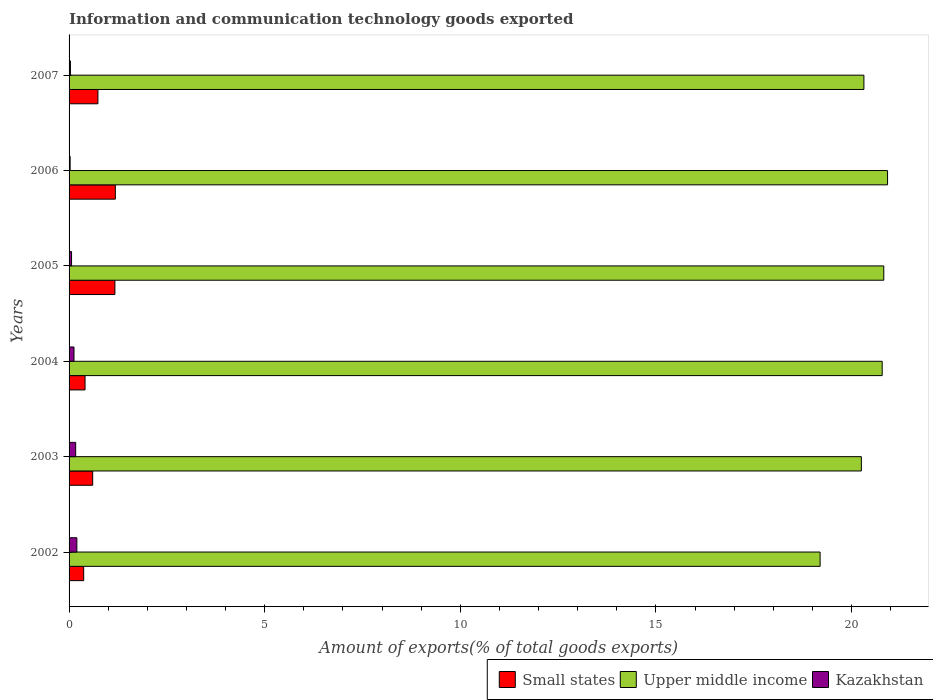How many different coloured bars are there?
Your response must be concise. 3. Are the number of bars per tick equal to the number of legend labels?
Make the answer very short. Yes. Are the number of bars on each tick of the Y-axis equal?
Keep it short and to the point. Yes. How many bars are there on the 1st tick from the top?
Give a very brief answer. 3. How many bars are there on the 6th tick from the bottom?
Offer a very short reply. 3. In how many cases, is the number of bars for a given year not equal to the number of legend labels?
Provide a succinct answer. 0. What is the amount of goods exported in Upper middle income in 2003?
Provide a succinct answer. 20.25. Across all years, what is the maximum amount of goods exported in Small states?
Keep it short and to the point. 1.18. Across all years, what is the minimum amount of goods exported in Small states?
Provide a short and direct response. 0.37. In which year was the amount of goods exported in Upper middle income maximum?
Give a very brief answer. 2006. What is the total amount of goods exported in Upper middle income in the graph?
Your answer should be very brief. 122.3. What is the difference between the amount of goods exported in Kazakhstan in 2002 and that in 2005?
Provide a short and direct response. 0.14. What is the difference between the amount of goods exported in Kazakhstan in 2004 and the amount of goods exported in Small states in 2005?
Your response must be concise. -1.05. What is the average amount of goods exported in Kazakhstan per year?
Your response must be concise. 0.1. In the year 2006, what is the difference between the amount of goods exported in Kazakhstan and amount of goods exported in Small states?
Your response must be concise. -1.16. In how many years, is the amount of goods exported in Small states greater than 6 %?
Make the answer very short. 0. What is the ratio of the amount of goods exported in Kazakhstan in 2004 to that in 2005?
Ensure brevity in your answer.  1.99. Is the difference between the amount of goods exported in Kazakhstan in 2003 and 2007 greater than the difference between the amount of goods exported in Small states in 2003 and 2007?
Ensure brevity in your answer.  Yes. What is the difference between the highest and the second highest amount of goods exported in Kazakhstan?
Your response must be concise. 0.03. What is the difference between the highest and the lowest amount of goods exported in Small states?
Provide a short and direct response. 0.81. In how many years, is the amount of goods exported in Upper middle income greater than the average amount of goods exported in Upper middle income taken over all years?
Your answer should be compact. 3. Is the sum of the amount of goods exported in Upper middle income in 2002 and 2004 greater than the maximum amount of goods exported in Small states across all years?
Offer a very short reply. Yes. What does the 2nd bar from the top in 2006 represents?
Ensure brevity in your answer.  Upper middle income. What does the 3rd bar from the bottom in 2005 represents?
Offer a very short reply. Kazakhstan. Are all the bars in the graph horizontal?
Your response must be concise. Yes. How many years are there in the graph?
Provide a succinct answer. 6. Does the graph contain any zero values?
Keep it short and to the point. No. Where does the legend appear in the graph?
Give a very brief answer. Bottom right. How many legend labels are there?
Your answer should be compact. 3. What is the title of the graph?
Your answer should be very brief. Information and communication technology goods exported. Does "Aruba" appear as one of the legend labels in the graph?
Your response must be concise. No. What is the label or title of the X-axis?
Offer a terse response. Amount of exports(% of total goods exports). What is the Amount of exports(% of total goods exports) of Small states in 2002?
Your answer should be compact. 0.37. What is the Amount of exports(% of total goods exports) of Upper middle income in 2002?
Make the answer very short. 19.2. What is the Amount of exports(% of total goods exports) of Kazakhstan in 2002?
Your answer should be very brief. 0.2. What is the Amount of exports(% of total goods exports) of Small states in 2003?
Provide a succinct answer. 0.6. What is the Amount of exports(% of total goods exports) of Upper middle income in 2003?
Your response must be concise. 20.25. What is the Amount of exports(% of total goods exports) of Kazakhstan in 2003?
Give a very brief answer. 0.17. What is the Amount of exports(% of total goods exports) in Small states in 2004?
Ensure brevity in your answer.  0.41. What is the Amount of exports(% of total goods exports) of Upper middle income in 2004?
Provide a succinct answer. 20.78. What is the Amount of exports(% of total goods exports) of Kazakhstan in 2004?
Your response must be concise. 0.13. What is the Amount of exports(% of total goods exports) in Small states in 2005?
Keep it short and to the point. 1.17. What is the Amount of exports(% of total goods exports) in Upper middle income in 2005?
Keep it short and to the point. 20.83. What is the Amount of exports(% of total goods exports) of Kazakhstan in 2005?
Keep it short and to the point. 0.06. What is the Amount of exports(% of total goods exports) in Small states in 2006?
Your response must be concise. 1.18. What is the Amount of exports(% of total goods exports) in Upper middle income in 2006?
Provide a short and direct response. 20.92. What is the Amount of exports(% of total goods exports) of Kazakhstan in 2006?
Provide a succinct answer. 0.03. What is the Amount of exports(% of total goods exports) in Small states in 2007?
Your answer should be compact. 0.74. What is the Amount of exports(% of total goods exports) in Upper middle income in 2007?
Ensure brevity in your answer.  20.32. What is the Amount of exports(% of total goods exports) of Kazakhstan in 2007?
Your answer should be very brief. 0.03. Across all years, what is the maximum Amount of exports(% of total goods exports) of Small states?
Keep it short and to the point. 1.18. Across all years, what is the maximum Amount of exports(% of total goods exports) in Upper middle income?
Your answer should be compact. 20.92. Across all years, what is the maximum Amount of exports(% of total goods exports) in Kazakhstan?
Your answer should be very brief. 0.2. Across all years, what is the minimum Amount of exports(% of total goods exports) in Small states?
Give a very brief answer. 0.37. Across all years, what is the minimum Amount of exports(% of total goods exports) in Upper middle income?
Make the answer very short. 19.2. Across all years, what is the minimum Amount of exports(% of total goods exports) in Kazakhstan?
Your response must be concise. 0.03. What is the total Amount of exports(% of total goods exports) of Small states in the graph?
Give a very brief answer. 4.48. What is the total Amount of exports(% of total goods exports) of Upper middle income in the graph?
Keep it short and to the point. 122.3. What is the total Amount of exports(% of total goods exports) in Kazakhstan in the graph?
Provide a short and direct response. 0.62. What is the difference between the Amount of exports(% of total goods exports) of Small states in 2002 and that in 2003?
Provide a short and direct response. -0.23. What is the difference between the Amount of exports(% of total goods exports) of Upper middle income in 2002 and that in 2003?
Your answer should be very brief. -1.05. What is the difference between the Amount of exports(% of total goods exports) of Kazakhstan in 2002 and that in 2003?
Offer a very short reply. 0.03. What is the difference between the Amount of exports(% of total goods exports) of Small states in 2002 and that in 2004?
Give a very brief answer. -0.03. What is the difference between the Amount of exports(% of total goods exports) of Upper middle income in 2002 and that in 2004?
Offer a terse response. -1.59. What is the difference between the Amount of exports(% of total goods exports) in Kazakhstan in 2002 and that in 2004?
Make the answer very short. 0.07. What is the difference between the Amount of exports(% of total goods exports) in Small states in 2002 and that in 2005?
Your answer should be very brief. -0.8. What is the difference between the Amount of exports(% of total goods exports) in Upper middle income in 2002 and that in 2005?
Give a very brief answer. -1.63. What is the difference between the Amount of exports(% of total goods exports) in Kazakhstan in 2002 and that in 2005?
Make the answer very short. 0.14. What is the difference between the Amount of exports(% of total goods exports) in Small states in 2002 and that in 2006?
Give a very brief answer. -0.81. What is the difference between the Amount of exports(% of total goods exports) in Upper middle income in 2002 and that in 2006?
Provide a short and direct response. -1.72. What is the difference between the Amount of exports(% of total goods exports) in Kazakhstan in 2002 and that in 2006?
Keep it short and to the point. 0.17. What is the difference between the Amount of exports(% of total goods exports) in Small states in 2002 and that in 2007?
Provide a succinct answer. -0.36. What is the difference between the Amount of exports(% of total goods exports) of Upper middle income in 2002 and that in 2007?
Offer a terse response. -1.12. What is the difference between the Amount of exports(% of total goods exports) in Kazakhstan in 2002 and that in 2007?
Your answer should be compact. 0.16. What is the difference between the Amount of exports(% of total goods exports) in Small states in 2003 and that in 2004?
Keep it short and to the point. 0.2. What is the difference between the Amount of exports(% of total goods exports) in Upper middle income in 2003 and that in 2004?
Make the answer very short. -0.53. What is the difference between the Amount of exports(% of total goods exports) in Kazakhstan in 2003 and that in 2004?
Give a very brief answer. 0.04. What is the difference between the Amount of exports(% of total goods exports) of Small states in 2003 and that in 2005?
Your answer should be compact. -0.57. What is the difference between the Amount of exports(% of total goods exports) in Upper middle income in 2003 and that in 2005?
Keep it short and to the point. -0.57. What is the difference between the Amount of exports(% of total goods exports) of Kazakhstan in 2003 and that in 2005?
Provide a short and direct response. 0.11. What is the difference between the Amount of exports(% of total goods exports) in Small states in 2003 and that in 2006?
Give a very brief answer. -0.58. What is the difference between the Amount of exports(% of total goods exports) of Upper middle income in 2003 and that in 2006?
Make the answer very short. -0.67. What is the difference between the Amount of exports(% of total goods exports) of Kazakhstan in 2003 and that in 2006?
Your answer should be compact. 0.14. What is the difference between the Amount of exports(% of total goods exports) of Small states in 2003 and that in 2007?
Make the answer very short. -0.13. What is the difference between the Amount of exports(% of total goods exports) of Upper middle income in 2003 and that in 2007?
Your answer should be compact. -0.06. What is the difference between the Amount of exports(% of total goods exports) of Kazakhstan in 2003 and that in 2007?
Ensure brevity in your answer.  0.13. What is the difference between the Amount of exports(% of total goods exports) in Small states in 2004 and that in 2005?
Your response must be concise. -0.76. What is the difference between the Amount of exports(% of total goods exports) of Upper middle income in 2004 and that in 2005?
Offer a very short reply. -0.04. What is the difference between the Amount of exports(% of total goods exports) of Kazakhstan in 2004 and that in 2005?
Provide a short and direct response. 0.06. What is the difference between the Amount of exports(% of total goods exports) of Small states in 2004 and that in 2006?
Your answer should be compact. -0.77. What is the difference between the Amount of exports(% of total goods exports) of Upper middle income in 2004 and that in 2006?
Offer a terse response. -0.14. What is the difference between the Amount of exports(% of total goods exports) of Kazakhstan in 2004 and that in 2006?
Ensure brevity in your answer.  0.1. What is the difference between the Amount of exports(% of total goods exports) in Small states in 2004 and that in 2007?
Your answer should be very brief. -0.33. What is the difference between the Amount of exports(% of total goods exports) of Upper middle income in 2004 and that in 2007?
Make the answer very short. 0.47. What is the difference between the Amount of exports(% of total goods exports) of Kazakhstan in 2004 and that in 2007?
Keep it short and to the point. 0.09. What is the difference between the Amount of exports(% of total goods exports) of Small states in 2005 and that in 2006?
Offer a terse response. -0.01. What is the difference between the Amount of exports(% of total goods exports) in Upper middle income in 2005 and that in 2006?
Provide a succinct answer. -0.1. What is the difference between the Amount of exports(% of total goods exports) in Kazakhstan in 2005 and that in 2006?
Make the answer very short. 0.04. What is the difference between the Amount of exports(% of total goods exports) in Small states in 2005 and that in 2007?
Give a very brief answer. 0.43. What is the difference between the Amount of exports(% of total goods exports) in Upper middle income in 2005 and that in 2007?
Your answer should be compact. 0.51. What is the difference between the Amount of exports(% of total goods exports) of Kazakhstan in 2005 and that in 2007?
Keep it short and to the point. 0.03. What is the difference between the Amount of exports(% of total goods exports) of Small states in 2006 and that in 2007?
Ensure brevity in your answer.  0.45. What is the difference between the Amount of exports(% of total goods exports) in Upper middle income in 2006 and that in 2007?
Your answer should be compact. 0.6. What is the difference between the Amount of exports(% of total goods exports) in Kazakhstan in 2006 and that in 2007?
Provide a short and direct response. -0.01. What is the difference between the Amount of exports(% of total goods exports) of Small states in 2002 and the Amount of exports(% of total goods exports) of Upper middle income in 2003?
Offer a very short reply. -19.88. What is the difference between the Amount of exports(% of total goods exports) of Small states in 2002 and the Amount of exports(% of total goods exports) of Kazakhstan in 2003?
Offer a terse response. 0.2. What is the difference between the Amount of exports(% of total goods exports) in Upper middle income in 2002 and the Amount of exports(% of total goods exports) in Kazakhstan in 2003?
Your answer should be very brief. 19.03. What is the difference between the Amount of exports(% of total goods exports) in Small states in 2002 and the Amount of exports(% of total goods exports) in Upper middle income in 2004?
Give a very brief answer. -20.41. What is the difference between the Amount of exports(% of total goods exports) of Small states in 2002 and the Amount of exports(% of total goods exports) of Kazakhstan in 2004?
Provide a succinct answer. 0.25. What is the difference between the Amount of exports(% of total goods exports) of Upper middle income in 2002 and the Amount of exports(% of total goods exports) of Kazakhstan in 2004?
Your response must be concise. 19.07. What is the difference between the Amount of exports(% of total goods exports) of Small states in 2002 and the Amount of exports(% of total goods exports) of Upper middle income in 2005?
Provide a short and direct response. -20.45. What is the difference between the Amount of exports(% of total goods exports) in Small states in 2002 and the Amount of exports(% of total goods exports) in Kazakhstan in 2005?
Keep it short and to the point. 0.31. What is the difference between the Amount of exports(% of total goods exports) of Upper middle income in 2002 and the Amount of exports(% of total goods exports) of Kazakhstan in 2005?
Your answer should be very brief. 19.13. What is the difference between the Amount of exports(% of total goods exports) of Small states in 2002 and the Amount of exports(% of total goods exports) of Upper middle income in 2006?
Your answer should be very brief. -20.55. What is the difference between the Amount of exports(% of total goods exports) of Small states in 2002 and the Amount of exports(% of total goods exports) of Kazakhstan in 2006?
Keep it short and to the point. 0.35. What is the difference between the Amount of exports(% of total goods exports) of Upper middle income in 2002 and the Amount of exports(% of total goods exports) of Kazakhstan in 2006?
Offer a very short reply. 19.17. What is the difference between the Amount of exports(% of total goods exports) in Small states in 2002 and the Amount of exports(% of total goods exports) in Upper middle income in 2007?
Your answer should be very brief. -19.94. What is the difference between the Amount of exports(% of total goods exports) of Small states in 2002 and the Amount of exports(% of total goods exports) of Kazakhstan in 2007?
Offer a very short reply. 0.34. What is the difference between the Amount of exports(% of total goods exports) in Upper middle income in 2002 and the Amount of exports(% of total goods exports) in Kazakhstan in 2007?
Ensure brevity in your answer.  19.16. What is the difference between the Amount of exports(% of total goods exports) in Small states in 2003 and the Amount of exports(% of total goods exports) in Upper middle income in 2004?
Your response must be concise. -20.18. What is the difference between the Amount of exports(% of total goods exports) in Small states in 2003 and the Amount of exports(% of total goods exports) in Kazakhstan in 2004?
Provide a succinct answer. 0.48. What is the difference between the Amount of exports(% of total goods exports) of Upper middle income in 2003 and the Amount of exports(% of total goods exports) of Kazakhstan in 2004?
Keep it short and to the point. 20.13. What is the difference between the Amount of exports(% of total goods exports) in Small states in 2003 and the Amount of exports(% of total goods exports) in Upper middle income in 2005?
Provide a short and direct response. -20.22. What is the difference between the Amount of exports(% of total goods exports) of Small states in 2003 and the Amount of exports(% of total goods exports) of Kazakhstan in 2005?
Keep it short and to the point. 0.54. What is the difference between the Amount of exports(% of total goods exports) in Upper middle income in 2003 and the Amount of exports(% of total goods exports) in Kazakhstan in 2005?
Offer a terse response. 20.19. What is the difference between the Amount of exports(% of total goods exports) of Small states in 2003 and the Amount of exports(% of total goods exports) of Upper middle income in 2006?
Make the answer very short. -20.32. What is the difference between the Amount of exports(% of total goods exports) of Small states in 2003 and the Amount of exports(% of total goods exports) of Kazakhstan in 2006?
Your response must be concise. 0.58. What is the difference between the Amount of exports(% of total goods exports) in Upper middle income in 2003 and the Amount of exports(% of total goods exports) in Kazakhstan in 2006?
Provide a short and direct response. 20.22. What is the difference between the Amount of exports(% of total goods exports) in Small states in 2003 and the Amount of exports(% of total goods exports) in Upper middle income in 2007?
Your answer should be very brief. -19.71. What is the difference between the Amount of exports(% of total goods exports) of Small states in 2003 and the Amount of exports(% of total goods exports) of Kazakhstan in 2007?
Give a very brief answer. 0.57. What is the difference between the Amount of exports(% of total goods exports) in Upper middle income in 2003 and the Amount of exports(% of total goods exports) in Kazakhstan in 2007?
Give a very brief answer. 20.22. What is the difference between the Amount of exports(% of total goods exports) in Small states in 2004 and the Amount of exports(% of total goods exports) in Upper middle income in 2005?
Give a very brief answer. -20.42. What is the difference between the Amount of exports(% of total goods exports) of Small states in 2004 and the Amount of exports(% of total goods exports) of Kazakhstan in 2005?
Your response must be concise. 0.35. What is the difference between the Amount of exports(% of total goods exports) of Upper middle income in 2004 and the Amount of exports(% of total goods exports) of Kazakhstan in 2005?
Offer a terse response. 20.72. What is the difference between the Amount of exports(% of total goods exports) in Small states in 2004 and the Amount of exports(% of total goods exports) in Upper middle income in 2006?
Your response must be concise. -20.51. What is the difference between the Amount of exports(% of total goods exports) in Small states in 2004 and the Amount of exports(% of total goods exports) in Kazakhstan in 2006?
Ensure brevity in your answer.  0.38. What is the difference between the Amount of exports(% of total goods exports) of Upper middle income in 2004 and the Amount of exports(% of total goods exports) of Kazakhstan in 2006?
Your response must be concise. 20.76. What is the difference between the Amount of exports(% of total goods exports) of Small states in 2004 and the Amount of exports(% of total goods exports) of Upper middle income in 2007?
Make the answer very short. -19.91. What is the difference between the Amount of exports(% of total goods exports) in Small states in 2004 and the Amount of exports(% of total goods exports) in Kazakhstan in 2007?
Provide a short and direct response. 0.37. What is the difference between the Amount of exports(% of total goods exports) of Upper middle income in 2004 and the Amount of exports(% of total goods exports) of Kazakhstan in 2007?
Keep it short and to the point. 20.75. What is the difference between the Amount of exports(% of total goods exports) in Small states in 2005 and the Amount of exports(% of total goods exports) in Upper middle income in 2006?
Keep it short and to the point. -19.75. What is the difference between the Amount of exports(% of total goods exports) of Small states in 2005 and the Amount of exports(% of total goods exports) of Kazakhstan in 2006?
Provide a succinct answer. 1.14. What is the difference between the Amount of exports(% of total goods exports) of Upper middle income in 2005 and the Amount of exports(% of total goods exports) of Kazakhstan in 2006?
Offer a very short reply. 20.8. What is the difference between the Amount of exports(% of total goods exports) of Small states in 2005 and the Amount of exports(% of total goods exports) of Upper middle income in 2007?
Offer a terse response. -19.15. What is the difference between the Amount of exports(% of total goods exports) in Small states in 2005 and the Amount of exports(% of total goods exports) in Kazakhstan in 2007?
Make the answer very short. 1.14. What is the difference between the Amount of exports(% of total goods exports) of Upper middle income in 2005 and the Amount of exports(% of total goods exports) of Kazakhstan in 2007?
Provide a succinct answer. 20.79. What is the difference between the Amount of exports(% of total goods exports) in Small states in 2006 and the Amount of exports(% of total goods exports) in Upper middle income in 2007?
Offer a very short reply. -19.13. What is the difference between the Amount of exports(% of total goods exports) in Small states in 2006 and the Amount of exports(% of total goods exports) in Kazakhstan in 2007?
Make the answer very short. 1.15. What is the difference between the Amount of exports(% of total goods exports) in Upper middle income in 2006 and the Amount of exports(% of total goods exports) in Kazakhstan in 2007?
Your answer should be compact. 20.89. What is the average Amount of exports(% of total goods exports) of Small states per year?
Provide a short and direct response. 0.75. What is the average Amount of exports(% of total goods exports) in Upper middle income per year?
Offer a very short reply. 20.38. What is the average Amount of exports(% of total goods exports) in Kazakhstan per year?
Provide a succinct answer. 0.1. In the year 2002, what is the difference between the Amount of exports(% of total goods exports) in Small states and Amount of exports(% of total goods exports) in Upper middle income?
Ensure brevity in your answer.  -18.82. In the year 2002, what is the difference between the Amount of exports(% of total goods exports) of Small states and Amount of exports(% of total goods exports) of Kazakhstan?
Offer a very short reply. 0.17. In the year 2002, what is the difference between the Amount of exports(% of total goods exports) in Upper middle income and Amount of exports(% of total goods exports) in Kazakhstan?
Offer a very short reply. 19. In the year 2003, what is the difference between the Amount of exports(% of total goods exports) in Small states and Amount of exports(% of total goods exports) in Upper middle income?
Your answer should be compact. -19.65. In the year 2003, what is the difference between the Amount of exports(% of total goods exports) of Small states and Amount of exports(% of total goods exports) of Kazakhstan?
Your response must be concise. 0.44. In the year 2003, what is the difference between the Amount of exports(% of total goods exports) in Upper middle income and Amount of exports(% of total goods exports) in Kazakhstan?
Ensure brevity in your answer.  20.08. In the year 2004, what is the difference between the Amount of exports(% of total goods exports) of Small states and Amount of exports(% of total goods exports) of Upper middle income?
Keep it short and to the point. -20.38. In the year 2004, what is the difference between the Amount of exports(% of total goods exports) in Small states and Amount of exports(% of total goods exports) in Kazakhstan?
Keep it short and to the point. 0.28. In the year 2004, what is the difference between the Amount of exports(% of total goods exports) of Upper middle income and Amount of exports(% of total goods exports) of Kazakhstan?
Ensure brevity in your answer.  20.66. In the year 2005, what is the difference between the Amount of exports(% of total goods exports) in Small states and Amount of exports(% of total goods exports) in Upper middle income?
Ensure brevity in your answer.  -19.65. In the year 2005, what is the difference between the Amount of exports(% of total goods exports) in Small states and Amount of exports(% of total goods exports) in Kazakhstan?
Your answer should be compact. 1.11. In the year 2005, what is the difference between the Amount of exports(% of total goods exports) of Upper middle income and Amount of exports(% of total goods exports) of Kazakhstan?
Make the answer very short. 20.76. In the year 2006, what is the difference between the Amount of exports(% of total goods exports) of Small states and Amount of exports(% of total goods exports) of Upper middle income?
Ensure brevity in your answer.  -19.74. In the year 2006, what is the difference between the Amount of exports(% of total goods exports) of Small states and Amount of exports(% of total goods exports) of Kazakhstan?
Offer a terse response. 1.16. In the year 2006, what is the difference between the Amount of exports(% of total goods exports) in Upper middle income and Amount of exports(% of total goods exports) in Kazakhstan?
Provide a succinct answer. 20.89. In the year 2007, what is the difference between the Amount of exports(% of total goods exports) in Small states and Amount of exports(% of total goods exports) in Upper middle income?
Your answer should be compact. -19.58. In the year 2007, what is the difference between the Amount of exports(% of total goods exports) in Small states and Amount of exports(% of total goods exports) in Kazakhstan?
Give a very brief answer. 0.7. In the year 2007, what is the difference between the Amount of exports(% of total goods exports) in Upper middle income and Amount of exports(% of total goods exports) in Kazakhstan?
Ensure brevity in your answer.  20.28. What is the ratio of the Amount of exports(% of total goods exports) of Small states in 2002 to that in 2003?
Your response must be concise. 0.62. What is the ratio of the Amount of exports(% of total goods exports) of Upper middle income in 2002 to that in 2003?
Your answer should be very brief. 0.95. What is the ratio of the Amount of exports(% of total goods exports) of Kazakhstan in 2002 to that in 2003?
Ensure brevity in your answer.  1.18. What is the ratio of the Amount of exports(% of total goods exports) in Small states in 2002 to that in 2004?
Make the answer very short. 0.91. What is the ratio of the Amount of exports(% of total goods exports) in Upper middle income in 2002 to that in 2004?
Provide a succinct answer. 0.92. What is the ratio of the Amount of exports(% of total goods exports) of Kazakhstan in 2002 to that in 2004?
Your response must be concise. 1.58. What is the ratio of the Amount of exports(% of total goods exports) of Small states in 2002 to that in 2005?
Provide a succinct answer. 0.32. What is the ratio of the Amount of exports(% of total goods exports) in Upper middle income in 2002 to that in 2005?
Provide a short and direct response. 0.92. What is the ratio of the Amount of exports(% of total goods exports) in Kazakhstan in 2002 to that in 2005?
Give a very brief answer. 3.14. What is the ratio of the Amount of exports(% of total goods exports) of Small states in 2002 to that in 2006?
Ensure brevity in your answer.  0.32. What is the ratio of the Amount of exports(% of total goods exports) in Upper middle income in 2002 to that in 2006?
Keep it short and to the point. 0.92. What is the ratio of the Amount of exports(% of total goods exports) of Kazakhstan in 2002 to that in 2006?
Give a very brief answer. 7.36. What is the ratio of the Amount of exports(% of total goods exports) of Small states in 2002 to that in 2007?
Give a very brief answer. 0.51. What is the ratio of the Amount of exports(% of total goods exports) of Upper middle income in 2002 to that in 2007?
Offer a terse response. 0.94. What is the ratio of the Amount of exports(% of total goods exports) of Kazakhstan in 2002 to that in 2007?
Give a very brief answer. 5.69. What is the ratio of the Amount of exports(% of total goods exports) in Small states in 2003 to that in 2004?
Your answer should be compact. 1.48. What is the ratio of the Amount of exports(% of total goods exports) of Upper middle income in 2003 to that in 2004?
Your answer should be very brief. 0.97. What is the ratio of the Amount of exports(% of total goods exports) of Kazakhstan in 2003 to that in 2004?
Keep it short and to the point. 1.34. What is the ratio of the Amount of exports(% of total goods exports) of Small states in 2003 to that in 2005?
Provide a short and direct response. 0.52. What is the ratio of the Amount of exports(% of total goods exports) in Upper middle income in 2003 to that in 2005?
Your answer should be compact. 0.97. What is the ratio of the Amount of exports(% of total goods exports) of Kazakhstan in 2003 to that in 2005?
Offer a very short reply. 2.66. What is the ratio of the Amount of exports(% of total goods exports) of Small states in 2003 to that in 2006?
Your answer should be very brief. 0.51. What is the ratio of the Amount of exports(% of total goods exports) of Upper middle income in 2003 to that in 2006?
Your answer should be very brief. 0.97. What is the ratio of the Amount of exports(% of total goods exports) of Kazakhstan in 2003 to that in 2006?
Ensure brevity in your answer.  6.23. What is the ratio of the Amount of exports(% of total goods exports) of Small states in 2003 to that in 2007?
Provide a short and direct response. 0.82. What is the ratio of the Amount of exports(% of total goods exports) of Upper middle income in 2003 to that in 2007?
Your answer should be compact. 1. What is the ratio of the Amount of exports(% of total goods exports) of Kazakhstan in 2003 to that in 2007?
Your answer should be very brief. 4.82. What is the ratio of the Amount of exports(% of total goods exports) of Small states in 2004 to that in 2005?
Your answer should be very brief. 0.35. What is the ratio of the Amount of exports(% of total goods exports) in Upper middle income in 2004 to that in 2005?
Your response must be concise. 1. What is the ratio of the Amount of exports(% of total goods exports) of Kazakhstan in 2004 to that in 2005?
Provide a succinct answer. 1.99. What is the ratio of the Amount of exports(% of total goods exports) in Small states in 2004 to that in 2006?
Offer a very short reply. 0.35. What is the ratio of the Amount of exports(% of total goods exports) of Upper middle income in 2004 to that in 2006?
Keep it short and to the point. 0.99. What is the ratio of the Amount of exports(% of total goods exports) of Kazakhstan in 2004 to that in 2006?
Ensure brevity in your answer.  4.66. What is the ratio of the Amount of exports(% of total goods exports) in Small states in 2004 to that in 2007?
Offer a very short reply. 0.55. What is the ratio of the Amount of exports(% of total goods exports) in Kazakhstan in 2004 to that in 2007?
Your response must be concise. 3.6. What is the ratio of the Amount of exports(% of total goods exports) of Small states in 2005 to that in 2006?
Your response must be concise. 0.99. What is the ratio of the Amount of exports(% of total goods exports) in Upper middle income in 2005 to that in 2006?
Offer a very short reply. 1. What is the ratio of the Amount of exports(% of total goods exports) in Kazakhstan in 2005 to that in 2006?
Your answer should be compact. 2.34. What is the ratio of the Amount of exports(% of total goods exports) of Small states in 2005 to that in 2007?
Your response must be concise. 1.59. What is the ratio of the Amount of exports(% of total goods exports) of Upper middle income in 2005 to that in 2007?
Ensure brevity in your answer.  1.02. What is the ratio of the Amount of exports(% of total goods exports) in Kazakhstan in 2005 to that in 2007?
Your answer should be compact. 1.81. What is the ratio of the Amount of exports(% of total goods exports) in Small states in 2006 to that in 2007?
Your response must be concise. 1.6. What is the ratio of the Amount of exports(% of total goods exports) of Upper middle income in 2006 to that in 2007?
Offer a very short reply. 1.03. What is the ratio of the Amount of exports(% of total goods exports) of Kazakhstan in 2006 to that in 2007?
Offer a terse response. 0.77. What is the difference between the highest and the second highest Amount of exports(% of total goods exports) in Small states?
Offer a very short reply. 0.01. What is the difference between the highest and the second highest Amount of exports(% of total goods exports) of Upper middle income?
Your answer should be compact. 0.1. What is the difference between the highest and the second highest Amount of exports(% of total goods exports) of Kazakhstan?
Ensure brevity in your answer.  0.03. What is the difference between the highest and the lowest Amount of exports(% of total goods exports) in Small states?
Your answer should be very brief. 0.81. What is the difference between the highest and the lowest Amount of exports(% of total goods exports) in Upper middle income?
Offer a terse response. 1.72. What is the difference between the highest and the lowest Amount of exports(% of total goods exports) of Kazakhstan?
Offer a terse response. 0.17. 